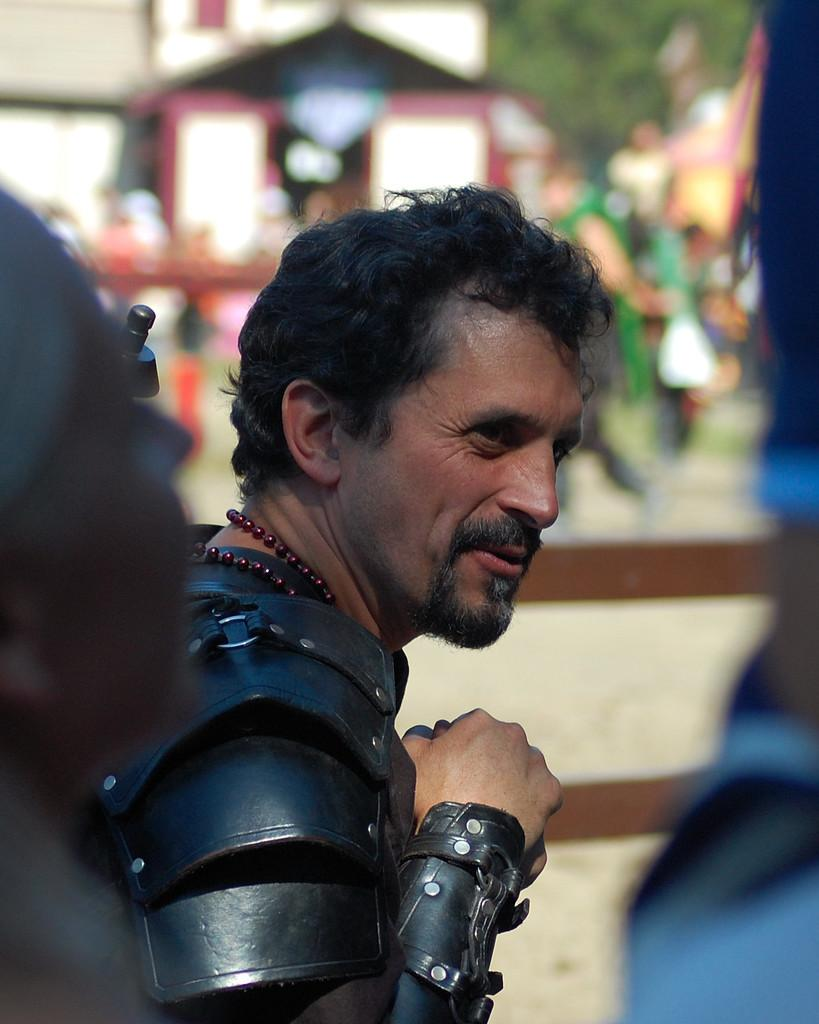Who is the main subject in the picture? There is a man in the center of the picture. What is the visual effect on the foreground and background of the image? The foreground and background are both blurred. What can be seen in the background of the image? There are people, buildings, and trees in the background. What type of needle is the man using to sew in the image? There is no needle present in the image, and the man is not shown sewing. Is the man holding a rifle in the image? There is no rifle present in the image; the man is the main subject, but no specific activity is depicted. 